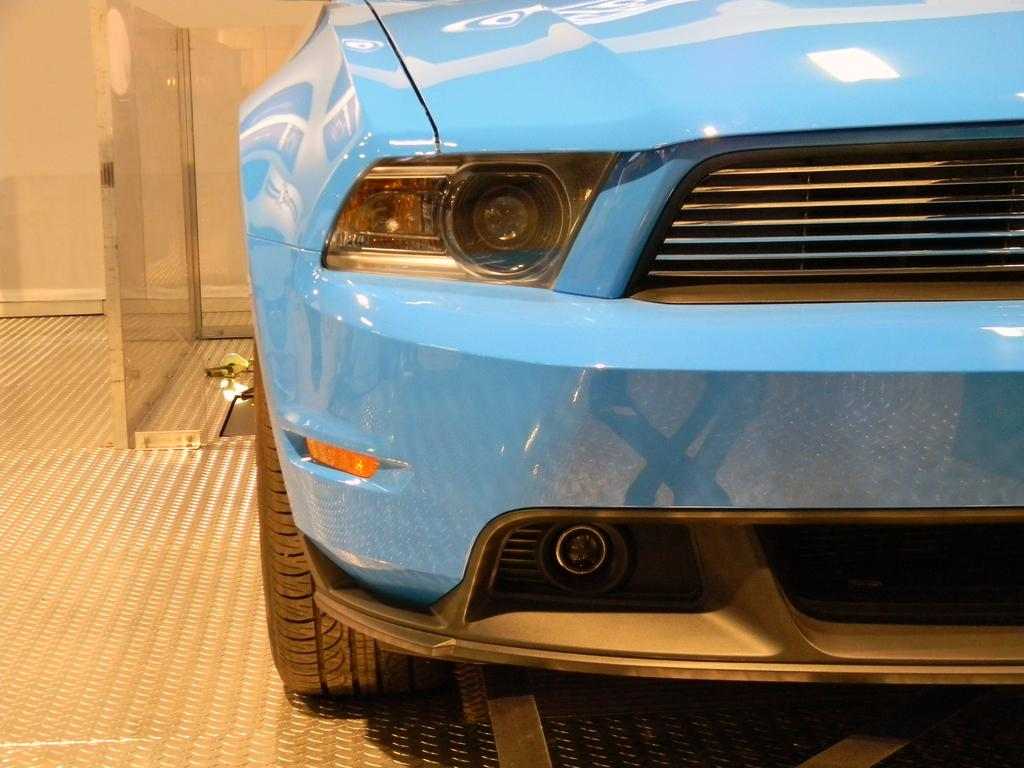What type of vehicle is in the image? There is a car in the image. What colors can be seen on the car? The car is blue and black in color. Where is the car located in the image? The car is on the floor. What type of surface is visible in the image? There is a glass surface in the image. What can be seen on the wall in the image? There is a cream-colored wall in the image. What object is located on the floor beside the car? There is an object on the floor beside the car, but its description is not provided in the facts. What type of brick is used to build the land in the image? There is no mention of brick or land in the image. The image features a car, a glass surface, a cream-colored wall, and an object on the floor beside the car. 